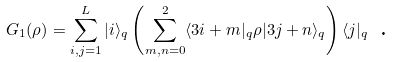<formula> <loc_0><loc_0><loc_500><loc_500>G _ { 1 } ( \rho ) = \sum _ { i , j = 1 } ^ { L } | i \rangle _ { q } \left ( \sum _ { m , n = 0 } ^ { 2 } \langle 3 i + m | _ { q } \rho | 3 j + n \rangle _ { q } \right ) \langle j | _ { q } \text { .}</formula> 